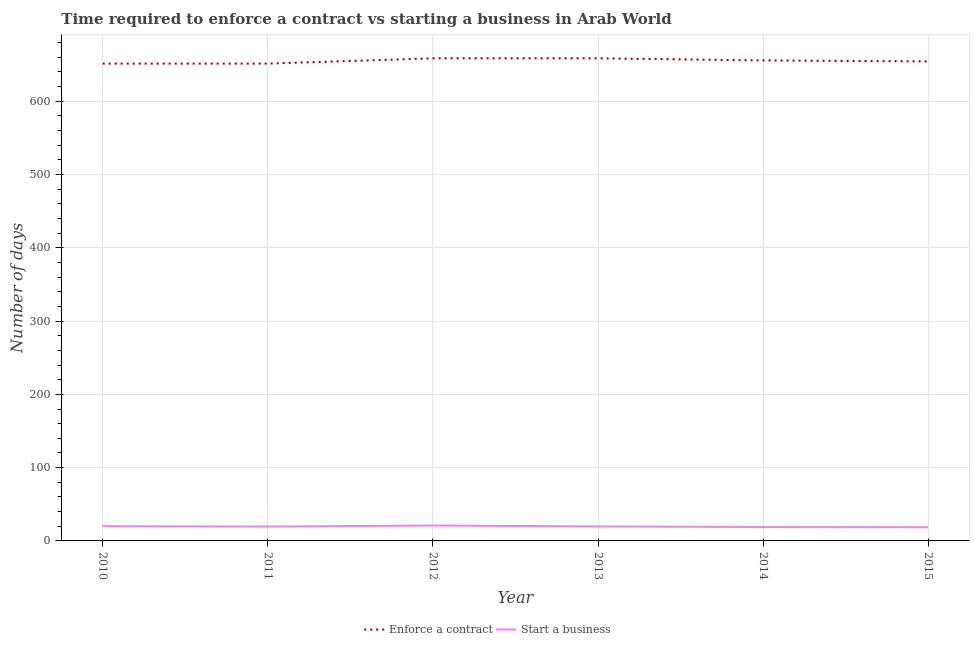How many different coloured lines are there?
Your response must be concise. 2. Does the line corresponding to number of days to start a business intersect with the line corresponding to number of days to enforece a contract?
Give a very brief answer. No. What is the number of days to start a business in 2010?
Provide a short and direct response. 20.12. Across all years, what is the maximum number of days to start a business?
Your response must be concise. 21.02. Across all years, what is the minimum number of days to start a business?
Provide a succinct answer. 18.69. In which year was the number of days to enforece a contract maximum?
Your response must be concise. 2012. What is the total number of days to enforece a contract in the graph?
Ensure brevity in your answer.  3930.28. What is the difference between the number of days to enforece a contract in 2013 and that in 2015?
Make the answer very short. 4.24. What is the difference between the number of days to start a business in 2015 and the number of days to enforece a contract in 2010?
Provide a short and direct response. -632.76. What is the average number of days to enforece a contract per year?
Offer a very short reply. 655.05. In the year 2011, what is the difference between the number of days to start a business and number of days to enforece a contract?
Offer a very short reply. -631.88. In how many years, is the number of days to enforece a contract greater than 480 days?
Provide a short and direct response. 6. What is the ratio of the number of days to enforece a contract in 2012 to that in 2015?
Give a very brief answer. 1.01. Is the number of days to start a business in 2010 less than that in 2013?
Keep it short and to the point. No. What is the difference between the highest and the lowest number of days to start a business?
Keep it short and to the point. 2.33. Is the sum of the number of days to enforece a contract in 2010 and 2015 greater than the maximum number of days to start a business across all years?
Make the answer very short. Yes. Does the number of days to start a business monotonically increase over the years?
Offer a terse response. No. Is the number of days to enforece a contract strictly greater than the number of days to start a business over the years?
Offer a terse response. Yes. Are the values on the major ticks of Y-axis written in scientific E-notation?
Provide a short and direct response. No. Does the graph contain any zero values?
Offer a very short reply. No. Does the graph contain grids?
Ensure brevity in your answer.  Yes. How many legend labels are there?
Offer a very short reply. 2. What is the title of the graph?
Provide a succinct answer. Time required to enforce a contract vs starting a business in Arab World. What is the label or title of the Y-axis?
Make the answer very short. Number of days. What is the Number of days of Enforce a contract in 2010?
Your response must be concise. 651.45. What is the Number of days of Start a business in 2010?
Your answer should be compact. 20.12. What is the Number of days of Enforce a contract in 2011?
Give a very brief answer. 651.45. What is the Number of days of Start a business in 2011?
Make the answer very short. 19.57. What is the Number of days in Enforce a contract in 2012?
Make the answer very short. 658.62. What is the Number of days of Start a business in 2012?
Ensure brevity in your answer.  21.02. What is the Number of days of Enforce a contract in 2013?
Your response must be concise. 658.62. What is the Number of days of Start a business in 2013?
Keep it short and to the point. 19.76. What is the Number of days in Enforce a contract in 2014?
Ensure brevity in your answer.  655.76. What is the Number of days in Start a business in 2014?
Make the answer very short. 18.95. What is the Number of days of Enforce a contract in 2015?
Your answer should be compact. 654.38. What is the Number of days of Start a business in 2015?
Offer a very short reply. 18.69. Across all years, what is the maximum Number of days in Enforce a contract?
Keep it short and to the point. 658.62. Across all years, what is the maximum Number of days in Start a business?
Make the answer very short. 21.02. Across all years, what is the minimum Number of days of Enforce a contract?
Keep it short and to the point. 651.45. Across all years, what is the minimum Number of days in Start a business?
Provide a succinct answer. 18.69. What is the total Number of days of Enforce a contract in the graph?
Provide a short and direct response. 3930.28. What is the total Number of days in Start a business in the graph?
Offer a terse response. 118.13. What is the difference between the Number of days of Enforce a contract in 2010 and that in 2011?
Your response must be concise. 0. What is the difference between the Number of days of Start a business in 2010 and that in 2011?
Keep it short and to the point. 0.55. What is the difference between the Number of days of Enforce a contract in 2010 and that in 2012?
Make the answer very short. -7.17. What is the difference between the Number of days of Start a business in 2010 and that in 2012?
Provide a succinct answer. -0.9. What is the difference between the Number of days of Enforce a contract in 2010 and that in 2013?
Your response must be concise. -7.17. What is the difference between the Number of days of Start a business in 2010 and that in 2013?
Make the answer very short. 0.36. What is the difference between the Number of days in Enforce a contract in 2010 and that in 2014?
Your response must be concise. -4.31. What is the difference between the Number of days in Start a business in 2010 and that in 2014?
Give a very brief answer. 1.17. What is the difference between the Number of days of Enforce a contract in 2010 and that in 2015?
Provide a short and direct response. -2.93. What is the difference between the Number of days in Start a business in 2010 and that in 2015?
Give a very brief answer. 1.43. What is the difference between the Number of days of Enforce a contract in 2011 and that in 2012?
Provide a short and direct response. -7.17. What is the difference between the Number of days in Start a business in 2011 and that in 2012?
Your response must be concise. -1.45. What is the difference between the Number of days of Enforce a contract in 2011 and that in 2013?
Your response must be concise. -7.17. What is the difference between the Number of days of Start a business in 2011 and that in 2013?
Offer a very short reply. -0.19. What is the difference between the Number of days of Enforce a contract in 2011 and that in 2014?
Provide a short and direct response. -4.31. What is the difference between the Number of days of Start a business in 2011 and that in 2014?
Make the answer very short. 0.62. What is the difference between the Number of days of Enforce a contract in 2011 and that in 2015?
Offer a very short reply. -2.93. What is the difference between the Number of days in Start a business in 2011 and that in 2015?
Provide a short and direct response. 0.88. What is the difference between the Number of days in Enforce a contract in 2012 and that in 2013?
Make the answer very short. 0. What is the difference between the Number of days of Start a business in 2012 and that in 2013?
Offer a very short reply. 1.26. What is the difference between the Number of days in Enforce a contract in 2012 and that in 2014?
Your response must be concise. 2.86. What is the difference between the Number of days in Start a business in 2012 and that in 2014?
Keep it short and to the point. 2.07. What is the difference between the Number of days in Enforce a contract in 2012 and that in 2015?
Ensure brevity in your answer.  4.24. What is the difference between the Number of days of Start a business in 2012 and that in 2015?
Offer a very short reply. 2.33. What is the difference between the Number of days in Enforce a contract in 2013 and that in 2014?
Make the answer very short. 2.86. What is the difference between the Number of days in Start a business in 2013 and that in 2014?
Provide a short and direct response. 0.81. What is the difference between the Number of days of Enforce a contract in 2013 and that in 2015?
Your answer should be very brief. 4.24. What is the difference between the Number of days in Start a business in 2013 and that in 2015?
Your response must be concise. 1.07. What is the difference between the Number of days in Enforce a contract in 2014 and that in 2015?
Keep it short and to the point. 1.38. What is the difference between the Number of days in Start a business in 2014 and that in 2015?
Provide a short and direct response. 0.26. What is the difference between the Number of days in Enforce a contract in 2010 and the Number of days in Start a business in 2011?
Your answer should be compact. 631.88. What is the difference between the Number of days of Enforce a contract in 2010 and the Number of days of Start a business in 2012?
Provide a succinct answer. 630.43. What is the difference between the Number of days in Enforce a contract in 2010 and the Number of days in Start a business in 2013?
Offer a terse response. 631.69. What is the difference between the Number of days of Enforce a contract in 2010 and the Number of days of Start a business in 2014?
Provide a succinct answer. 632.5. What is the difference between the Number of days of Enforce a contract in 2010 and the Number of days of Start a business in 2015?
Offer a very short reply. 632.76. What is the difference between the Number of days of Enforce a contract in 2011 and the Number of days of Start a business in 2012?
Your answer should be very brief. 630.43. What is the difference between the Number of days in Enforce a contract in 2011 and the Number of days in Start a business in 2013?
Your answer should be compact. 631.69. What is the difference between the Number of days of Enforce a contract in 2011 and the Number of days of Start a business in 2014?
Ensure brevity in your answer.  632.5. What is the difference between the Number of days of Enforce a contract in 2011 and the Number of days of Start a business in 2015?
Give a very brief answer. 632.76. What is the difference between the Number of days in Enforce a contract in 2012 and the Number of days in Start a business in 2013?
Offer a terse response. 638.86. What is the difference between the Number of days in Enforce a contract in 2012 and the Number of days in Start a business in 2014?
Keep it short and to the point. 639.67. What is the difference between the Number of days of Enforce a contract in 2012 and the Number of days of Start a business in 2015?
Your answer should be compact. 639.93. What is the difference between the Number of days in Enforce a contract in 2013 and the Number of days in Start a business in 2014?
Your answer should be very brief. 639.67. What is the difference between the Number of days of Enforce a contract in 2013 and the Number of days of Start a business in 2015?
Offer a very short reply. 639.93. What is the difference between the Number of days in Enforce a contract in 2014 and the Number of days in Start a business in 2015?
Offer a terse response. 637.07. What is the average Number of days in Enforce a contract per year?
Make the answer very short. 655.05. What is the average Number of days of Start a business per year?
Provide a succinct answer. 19.69. In the year 2010, what is the difference between the Number of days of Enforce a contract and Number of days of Start a business?
Give a very brief answer. 631.33. In the year 2011, what is the difference between the Number of days in Enforce a contract and Number of days in Start a business?
Provide a short and direct response. 631.88. In the year 2012, what is the difference between the Number of days in Enforce a contract and Number of days in Start a business?
Ensure brevity in your answer.  637.6. In the year 2013, what is the difference between the Number of days in Enforce a contract and Number of days in Start a business?
Your response must be concise. 638.86. In the year 2014, what is the difference between the Number of days of Enforce a contract and Number of days of Start a business?
Your response must be concise. 636.81. In the year 2015, what is the difference between the Number of days of Enforce a contract and Number of days of Start a business?
Your answer should be compact. 635.69. What is the ratio of the Number of days of Start a business in 2010 to that in 2011?
Give a very brief answer. 1.03. What is the ratio of the Number of days in Enforce a contract in 2010 to that in 2012?
Make the answer very short. 0.99. What is the ratio of the Number of days of Start a business in 2010 to that in 2012?
Give a very brief answer. 0.96. What is the ratio of the Number of days in Enforce a contract in 2010 to that in 2013?
Make the answer very short. 0.99. What is the ratio of the Number of days in Start a business in 2010 to that in 2013?
Your response must be concise. 1.02. What is the ratio of the Number of days in Start a business in 2010 to that in 2014?
Ensure brevity in your answer.  1.06. What is the ratio of the Number of days of Start a business in 2010 to that in 2015?
Offer a very short reply. 1.08. What is the ratio of the Number of days in Start a business in 2011 to that in 2012?
Provide a short and direct response. 0.93. What is the ratio of the Number of days of Enforce a contract in 2011 to that in 2013?
Offer a very short reply. 0.99. What is the ratio of the Number of days of Enforce a contract in 2011 to that in 2014?
Your answer should be very brief. 0.99. What is the ratio of the Number of days in Start a business in 2011 to that in 2014?
Provide a short and direct response. 1.03. What is the ratio of the Number of days of Start a business in 2011 to that in 2015?
Provide a succinct answer. 1.05. What is the ratio of the Number of days in Start a business in 2012 to that in 2013?
Keep it short and to the point. 1.06. What is the ratio of the Number of days of Enforce a contract in 2012 to that in 2014?
Provide a short and direct response. 1. What is the ratio of the Number of days in Start a business in 2012 to that in 2014?
Your answer should be compact. 1.11. What is the ratio of the Number of days in Start a business in 2012 to that in 2015?
Make the answer very short. 1.12. What is the ratio of the Number of days of Start a business in 2013 to that in 2014?
Keep it short and to the point. 1.04. What is the ratio of the Number of days of Enforce a contract in 2013 to that in 2015?
Ensure brevity in your answer.  1.01. What is the ratio of the Number of days in Start a business in 2013 to that in 2015?
Provide a succinct answer. 1.06. What is the ratio of the Number of days in Enforce a contract in 2014 to that in 2015?
Your response must be concise. 1. What is the difference between the highest and the second highest Number of days of Start a business?
Keep it short and to the point. 0.9. What is the difference between the highest and the lowest Number of days of Enforce a contract?
Your response must be concise. 7.17. What is the difference between the highest and the lowest Number of days of Start a business?
Your answer should be compact. 2.33. 